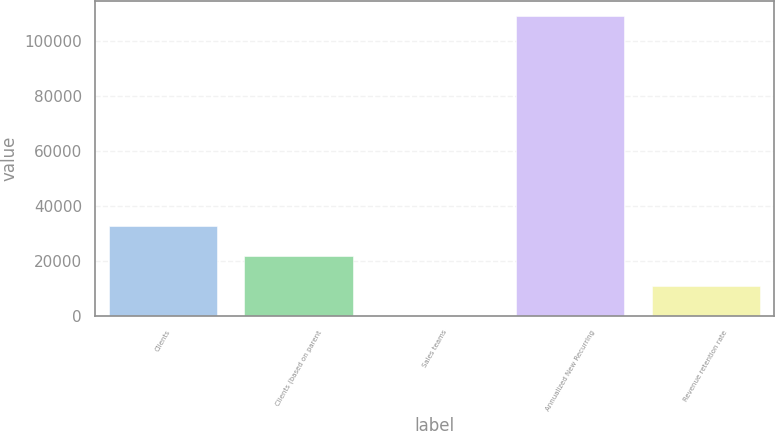<chart> <loc_0><loc_0><loc_500><loc_500><bar_chart><fcel>Clients<fcel>Clients (based on parent<fcel>Sales teams<fcel>Annualized New Recurring<fcel>Revenue retention rate<nl><fcel>32715.3<fcel>21822.2<fcel>36<fcel>108967<fcel>10929.1<nl></chart> 